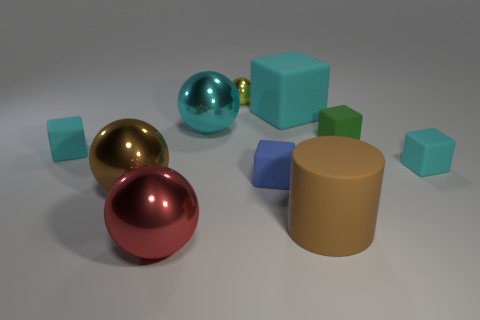What number of cylinders are the same material as the small blue block?
Your response must be concise. 1. What number of green rubber spheres have the same size as the red metal sphere?
Your answer should be compact. 0. There is a small cyan thing that is in front of the tiny cyan matte cube that is behind the tiny cyan rubber thing right of the tiny ball; what is its material?
Ensure brevity in your answer.  Rubber. How many objects are large red shiny balls or tiny yellow things?
Give a very brief answer. 2. Is there anything else that is the same material as the big brown cylinder?
Ensure brevity in your answer.  Yes. What is the shape of the big cyan shiny object?
Provide a short and direct response. Sphere. There is a large rubber thing in front of the small rubber object that is on the left side of the large red thing; what shape is it?
Offer a very short reply. Cylinder. Do the tiny cyan block that is to the right of the small blue rubber object and the tiny green thing have the same material?
Your response must be concise. Yes. What number of cyan objects are spheres or cubes?
Provide a succinct answer. 4. Are there any shiny objects that have the same color as the cylinder?
Offer a very short reply. Yes. 